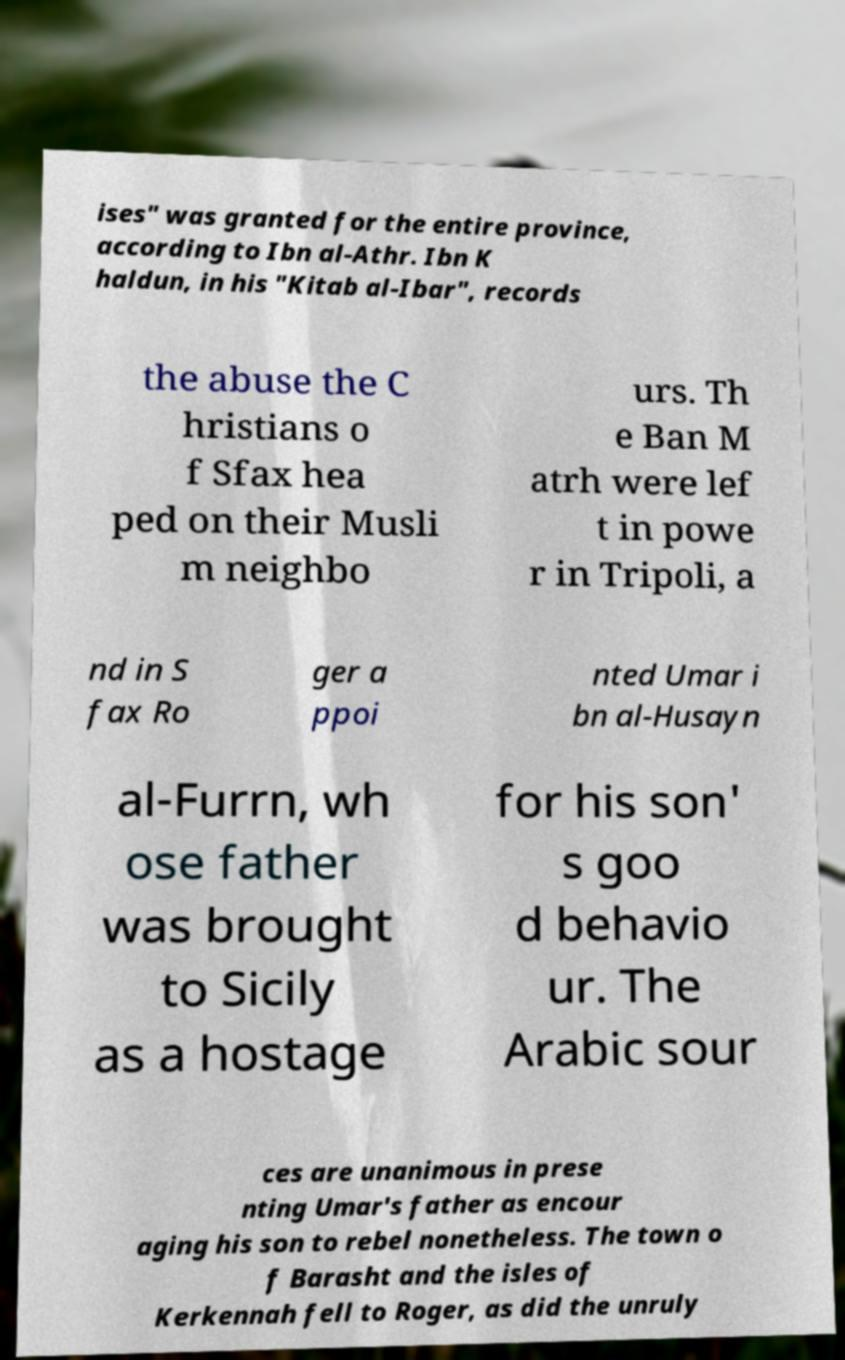What messages or text are displayed in this image? I need them in a readable, typed format. ises" was granted for the entire province, according to Ibn al-Athr. Ibn K haldun, in his "Kitab al-Ibar", records the abuse the C hristians o f Sfax hea ped on their Musli m neighbo urs. Th e Ban M atrh were lef t in powe r in Tripoli, a nd in S fax Ro ger a ppoi nted Umar i bn al-Husayn al-Furrn, wh ose father was brought to Sicily as a hostage for his son' s goo d behavio ur. The Arabic sour ces are unanimous in prese nting Umar's father as encour aging his son to rebel nonetheless. The town o f Barasht and the isles of Kerkennah fell to Roger, as did the unruly 